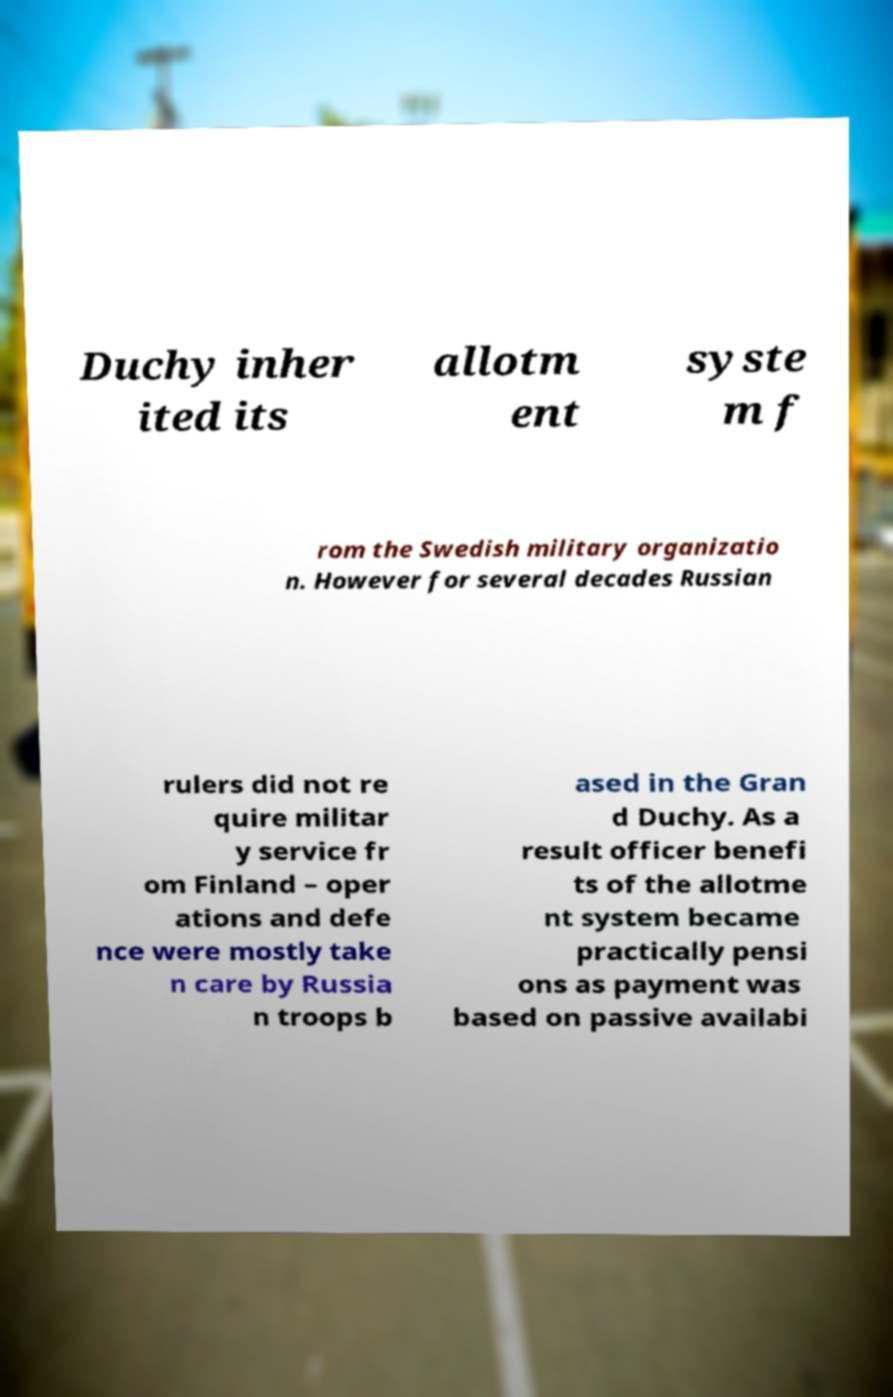Please identify and transcribe the text found in this image. Duchy inher ited its allotm ent syste m f rom the Swedish military organizatio n. However for several decades Russian rulers did not re quire militar y service fr om Finland – oper ations and defe nce were mostly take n care by Russia n troops b ased in the Gran d Duchy. As a result officer benefi ts of the allotme nt system became practically pensi ons as payment was based on passive availabi 